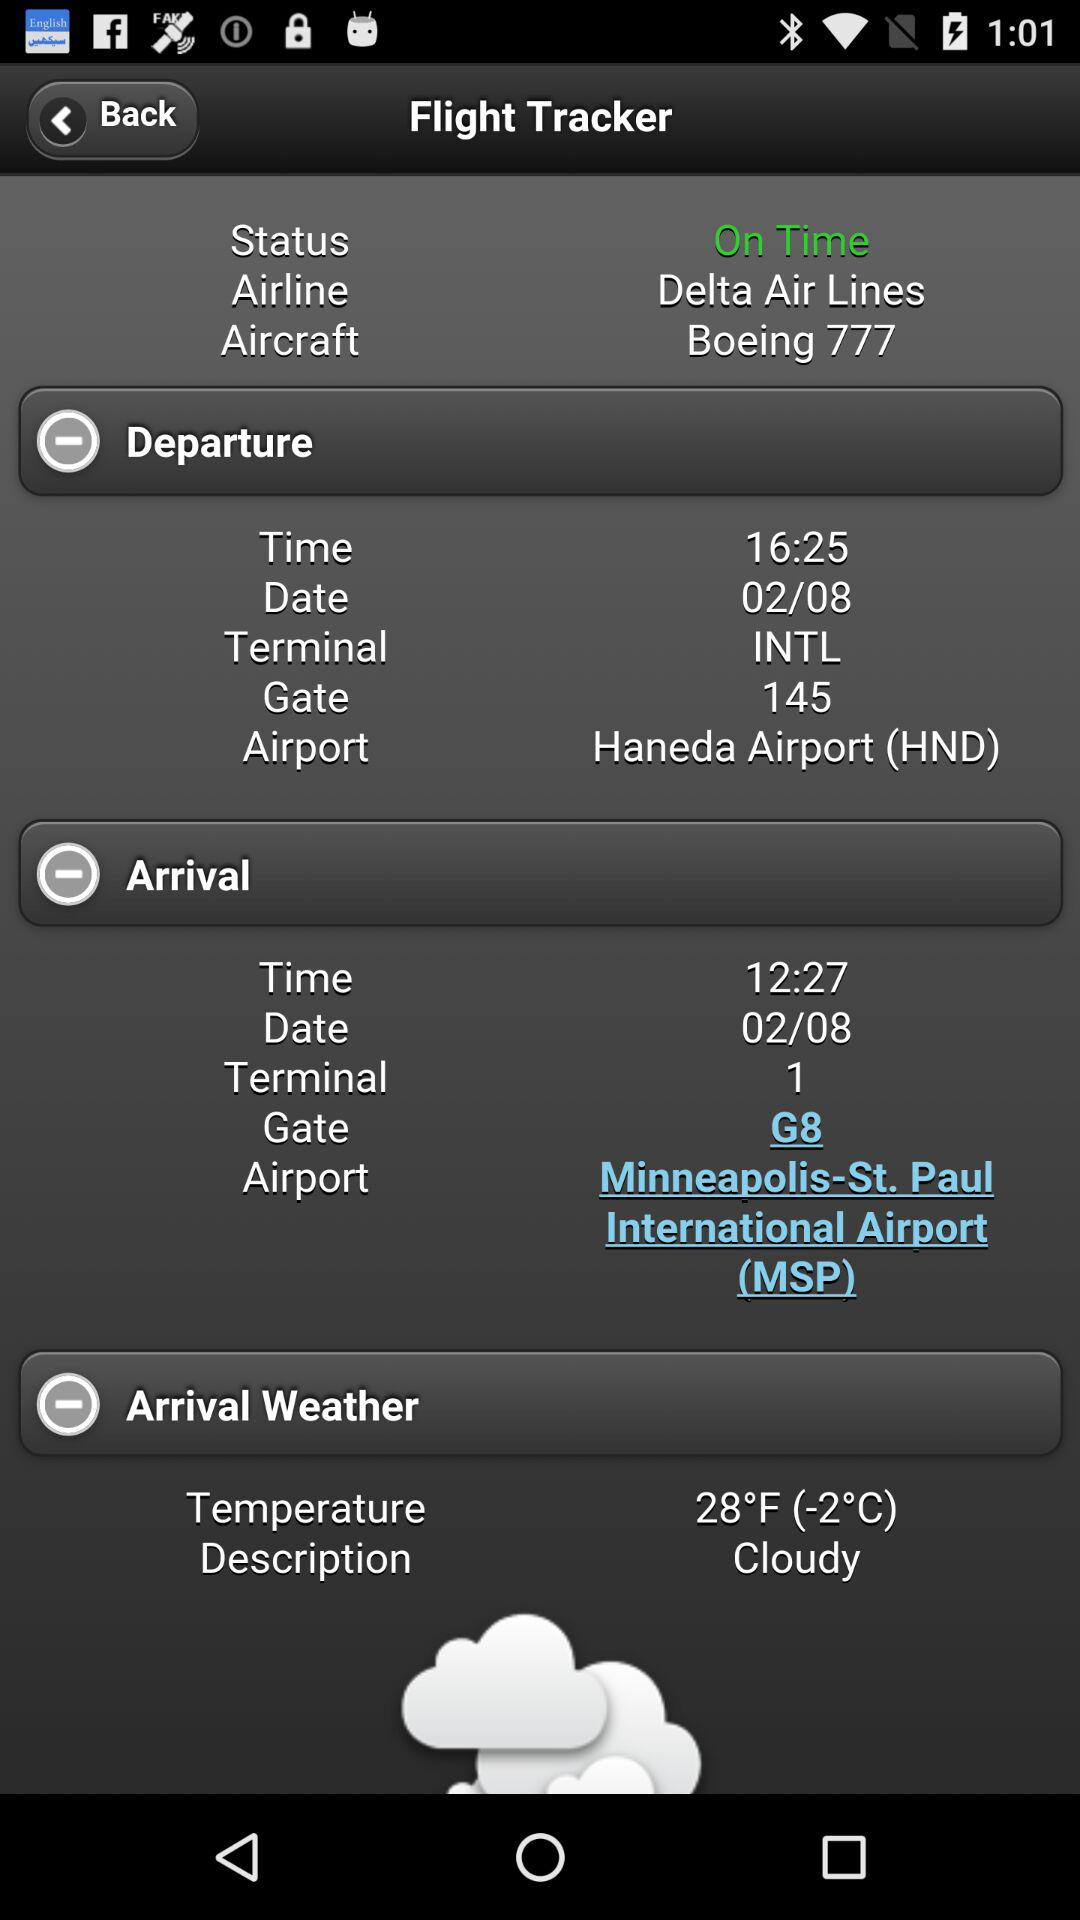What type of arrival weather is it? The arrival weather is "Cloudy". 